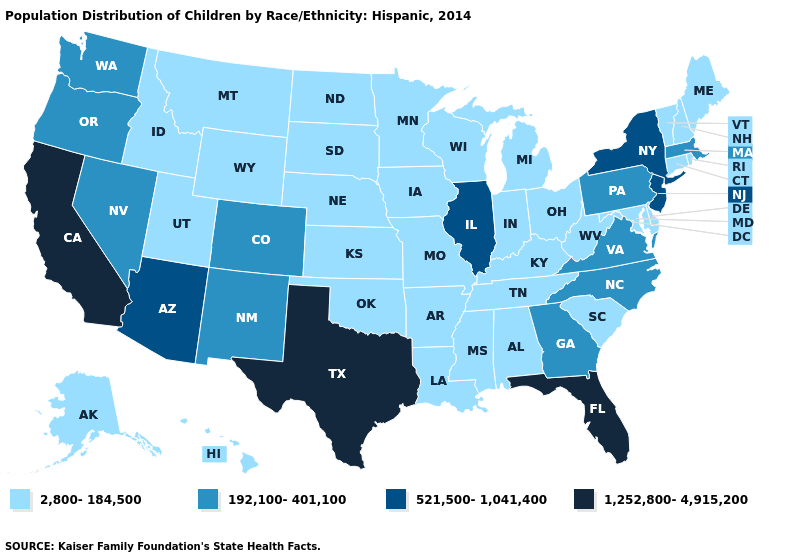Among the states that border Louisiana , which have the highest value?
Short answer required. Texas. Does New Mexico have a lower value than Arizona?
Short answer required. Yes. What is the value of Indiana?
Write a very short answer. 2,800-184,500. Name the states that have a value in the range 1,252,800-4,915,200?
Answer briefly. California, Florida, Texas. Name the states that have a value in the range 1,252,800-4,915,200?
Answer briefly. California, Florida, Texas. Name the states that have a value in the range 521,500-1,041,400?
Answer briefly. Arizona, Illinois, New Jersey, New York. Does Nevada have the highest value in the USA?
Give a very brief answer. No. Does Tennessee have the lowest value in the USA?
Answer briefly. Yes. Name the states that have a value in the range 1,252,800-4,915,200?
Keep it brief. California, Florida, Texas. Name the states that have a value in the range 192,100-401,100?
Answer briefly. Colorado, Georgia, Massachusetts, Nevada, New Mexico, North Carolina, Oregon, Pennsylvania, Virginia, Washington. Does the map have missing data?
Quick response, please. No. Among the states that border Tennessee , which have the highest value?
Write a very short answer. Georgia, North Carolina, Virginia. Is the legend a continuous bar?
Short answer required. No. What is the value of Florida?
Keep it brief. 1,252,800-4,915,200. 